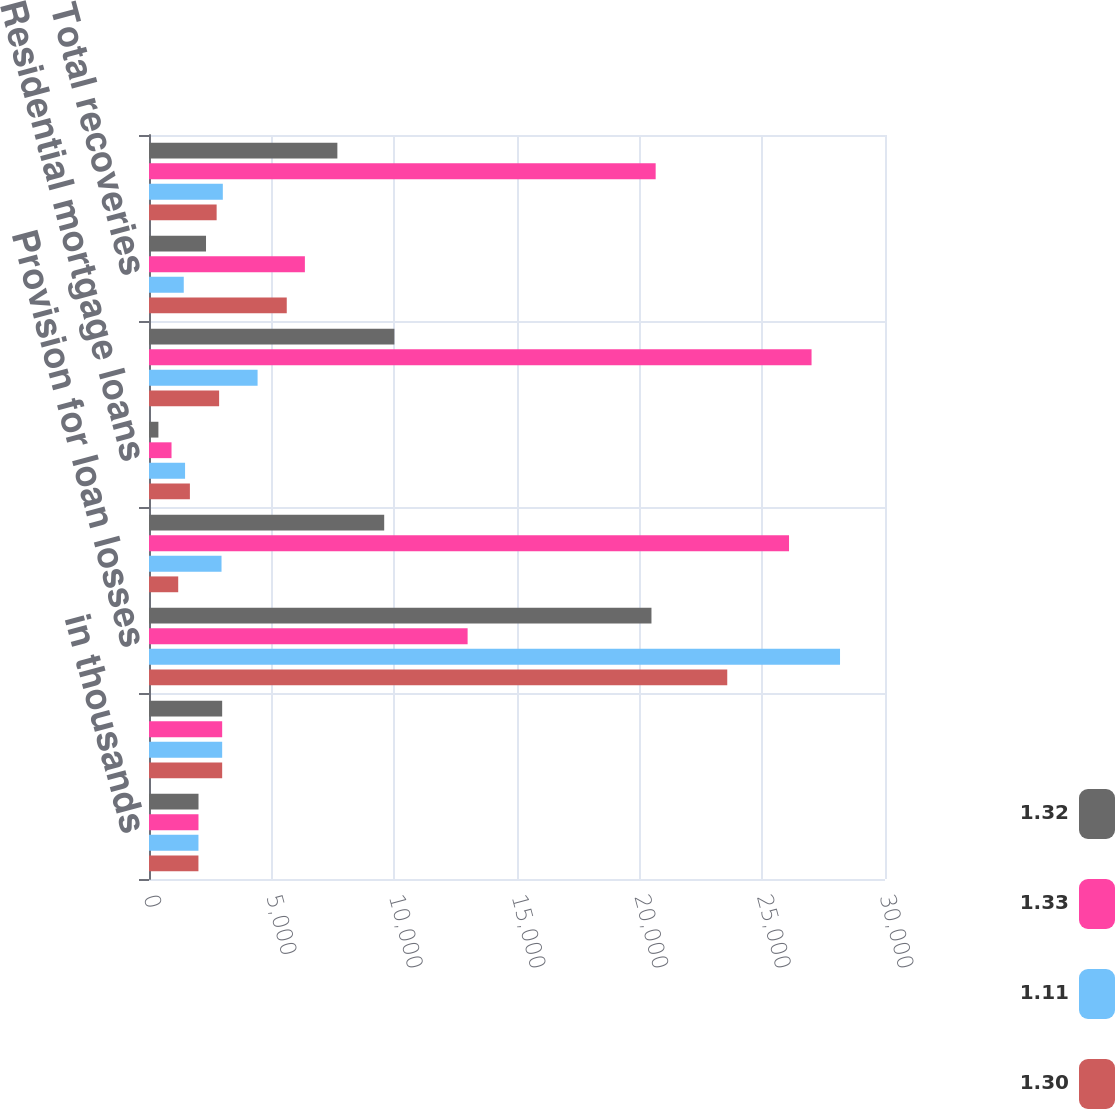Convert chart. <chart><loc_0><loc_0><loc_500><loc_500><stacked_bar_chart><ecel><fcel>in thousands<fcel>Allowance for loan losses<fcel>Provision for loan losses<fcel>C&I loans<fcel>Residential mortgage loans<fcel>Total charge-offs<fcel>Total recoveries<fcel>Net (charge-offs)/recoveries<nl><fcel>1.32<fcel>2018<fcel>2982.5<fcel>20481<fcel>9587<fcel>383<fcel>10002<fcel>2324<fcel>7678<nl><fcel>1.33<fcel>2017<fcel>2982.5<fcel>12987<fcel>26088<fcel>918<fcel>27006<fcel>6354<fcel>20652<nl><fcel>1.11<fcel>2016<fcel>2982.5<fcel>28167<fcel>2956<fcel>1470<fcel>4426<fcel>1417<fcel>3009<nl><fcel>1.3<fcel>2015<fcel>2982.5<fcel>23570<fcel>1191<fcel>1667<fcel>2858<fcel>5615<fcel>2757<nl></chart> 